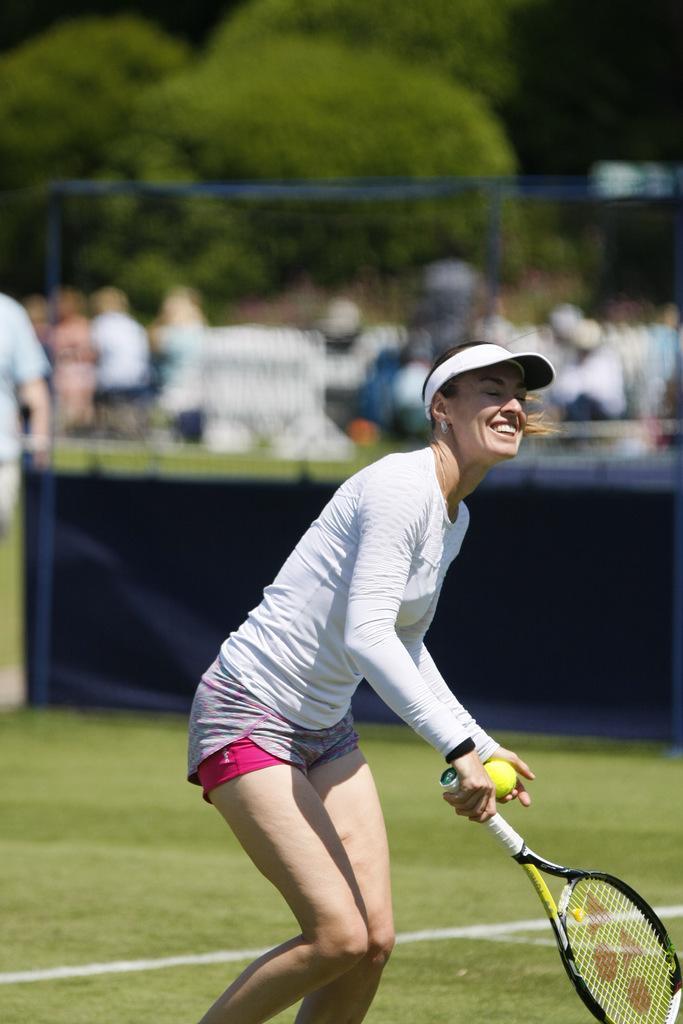Please provide a concise description of this image. In this picture there is a woman who smiling and standing, she is holding a tennis ball and tennis racket and in the backdrop there is crowd, trees. 